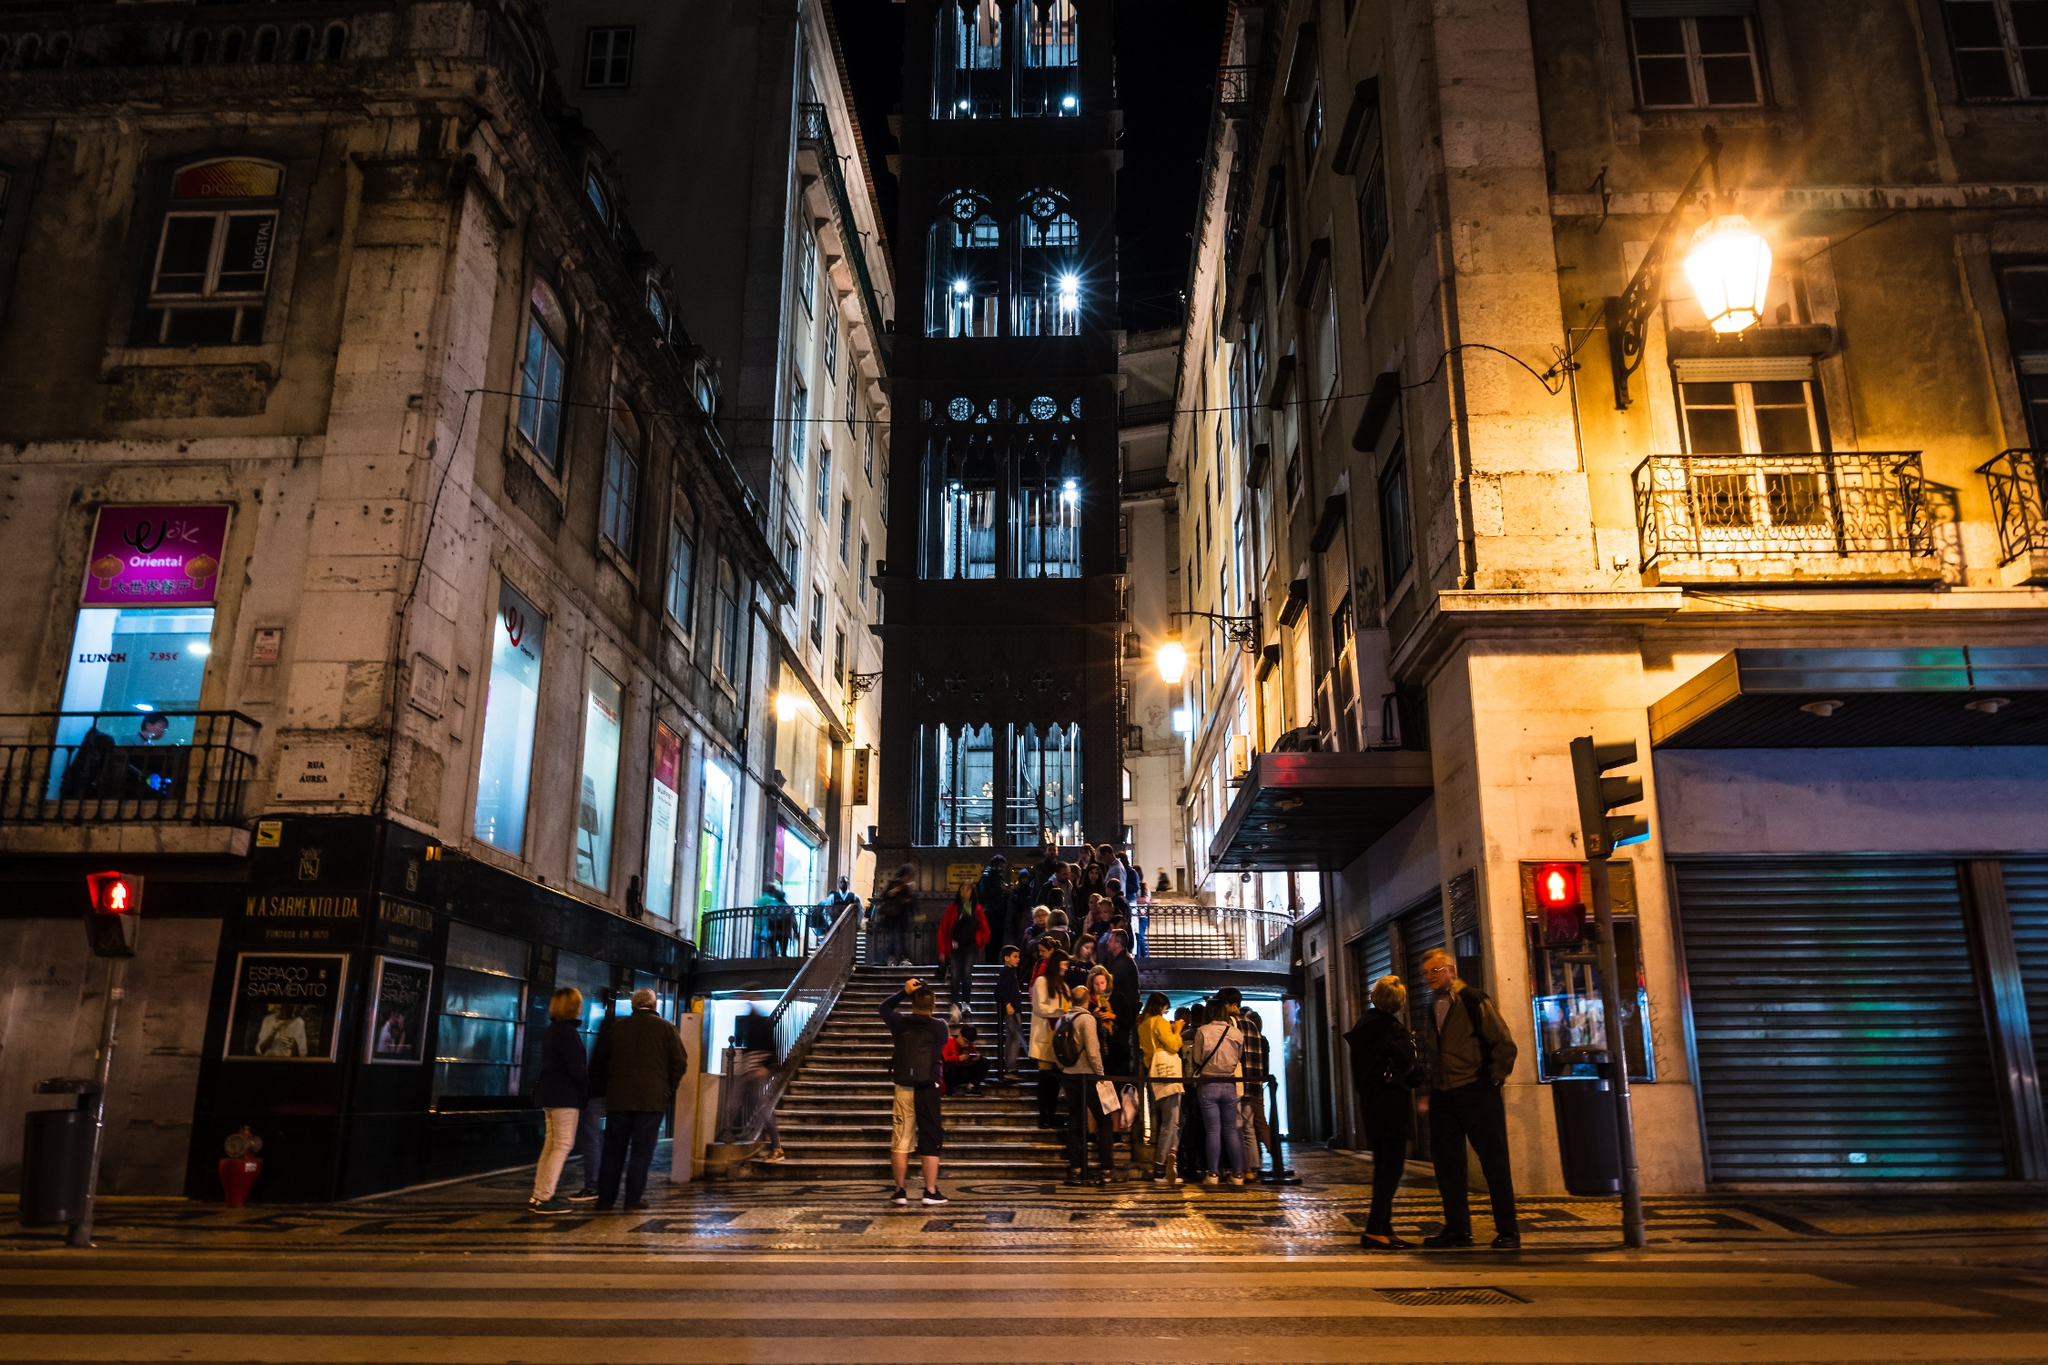What might be the historical significance of this location? The Santa Justa Lift, also known as Carmo Lift, holds significant historical value in Lisbon. Opened in 1902, it was designed by Raul Mesnier de Ponsard, an engineer who was inspired by the works of Gustave Eiffel. The lift was constructed to connect the lower streets of Baixa with the higher Largo do Carmo, making the steep climb easier for the city's residents. Over the years, it has become both a practical mode of transportation and a popular tourist attraction, symbolizing Lisbon's blend of historic charm and modern advancement. 